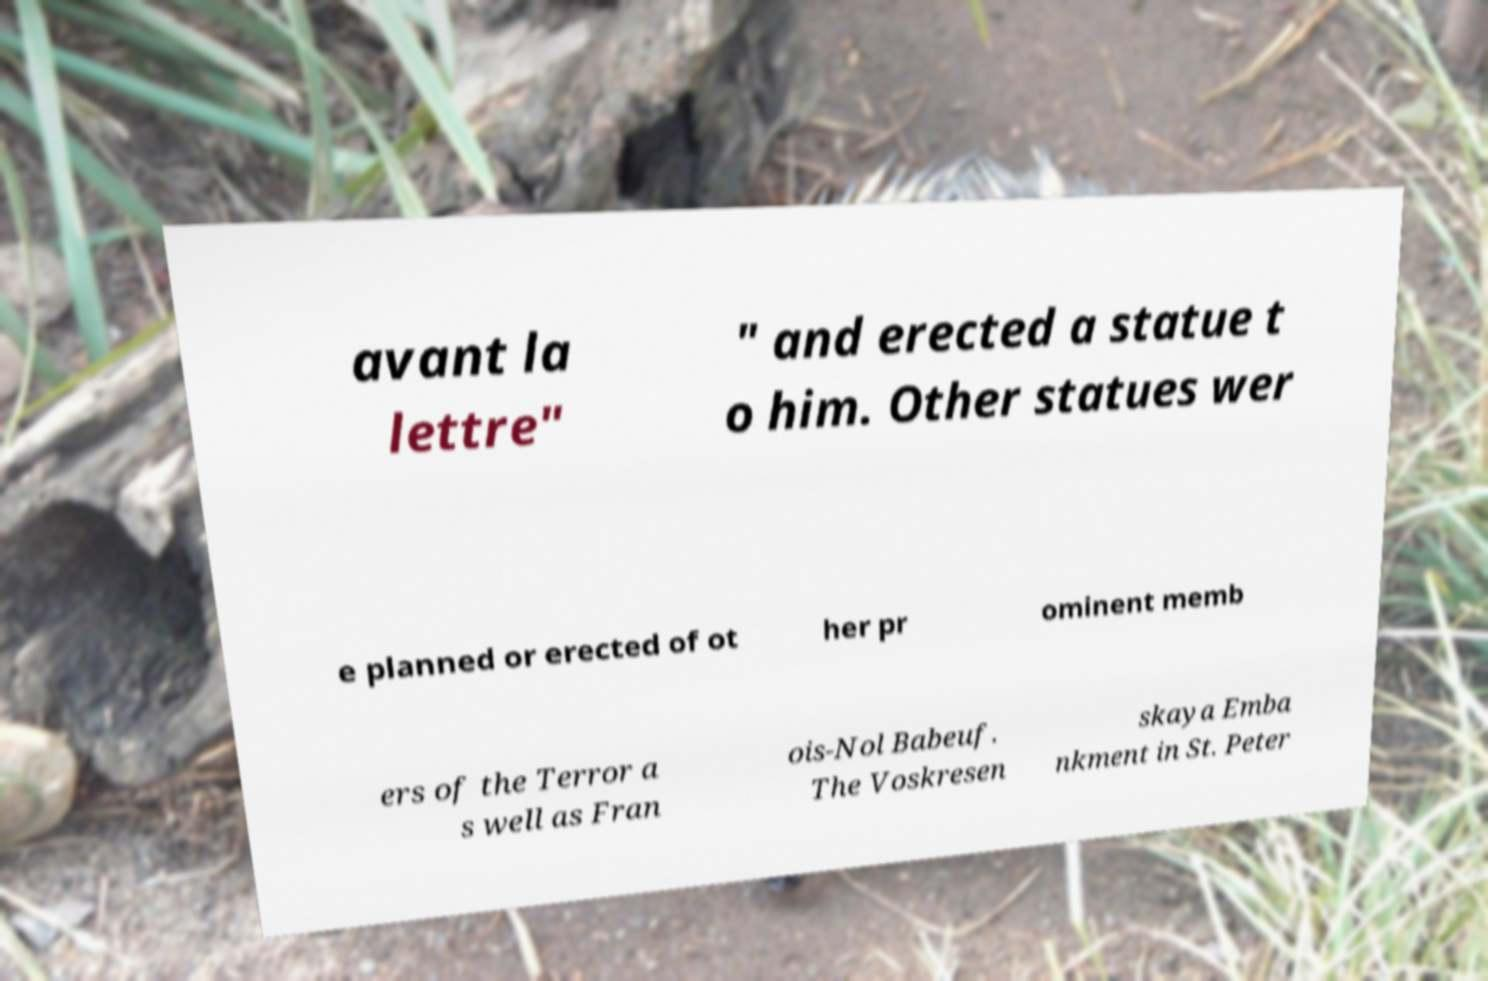I need the written content from this picture converted into text. Can you do that? avant la lettre" " and erected a statue t o him. Other statues wer e planned or erected of ot her pr ominent memb ers of the Terror a s well as Fran ois-Nol Babeuf. The Voskresen skaya Emba nkment in St. Peter 